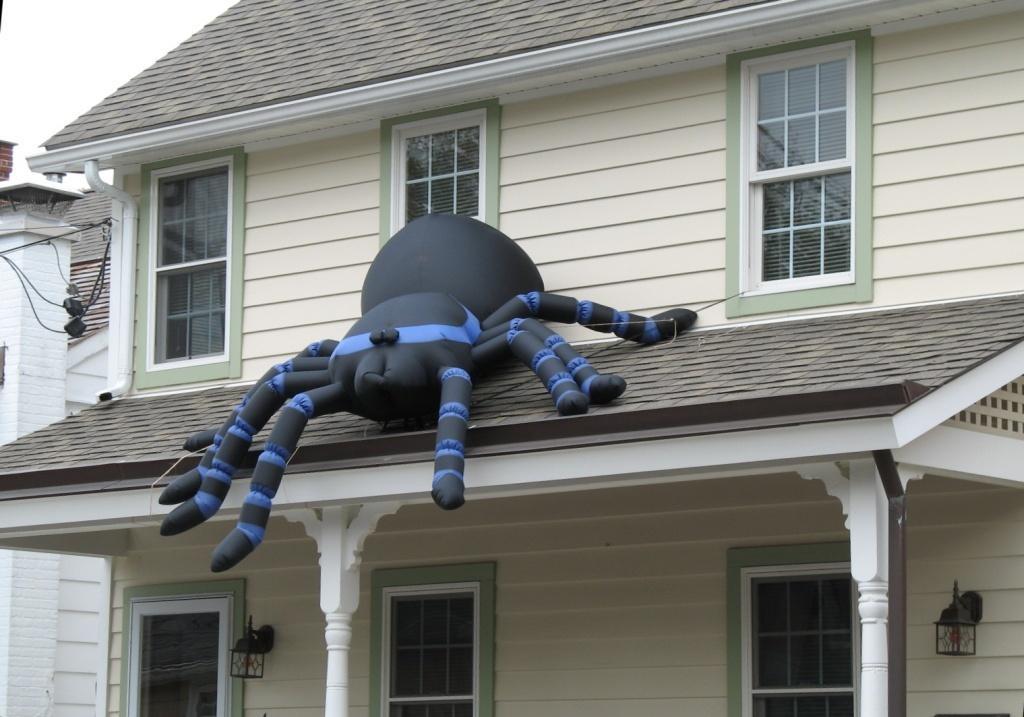In one or two sentences, can you explain what this image depicts? There is one inflatable thing is present in the middle of this image, and there is a building in the background. We can see a sky in the top left corner of this image. 